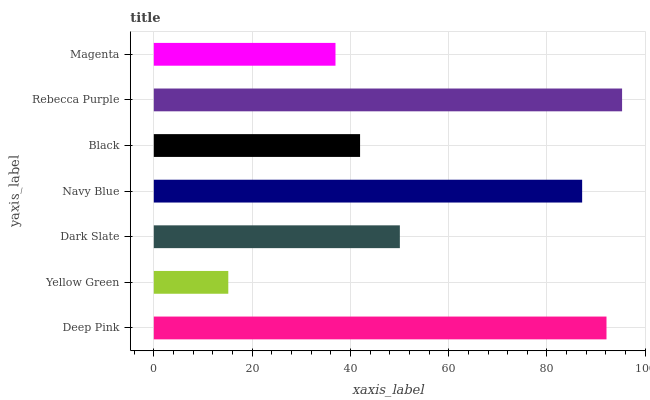Is Yellow Green the minimum?
Answer yes or no. Yes. Is Rebecca Purple the maximum?
Answer yes or no. Yes. Is Dark Slate the minimum?
Answer yes or no. No. Is Dark Slate the maximum?
Answer yes or no. No. Is Dark Slate greater than Yellow Green?
Answer yes or no. Yes. Is Yellow Green less than Dark Slate?
Answer yes or no. Yes. Is Yellow Green greater than Dark Slate?
Answer yes or no. No. Is Dark Slate less than Yellow Green?
Answer yes or no. No. Is Dark Slate the high median?
Answer yes or no. Yes. Is Dark Slate the low median?
Answer yes or no. Yes. Is Black the high median?
Answer yes or no. No. Is Yellow Green the low median?
Answer yes or no. No. 